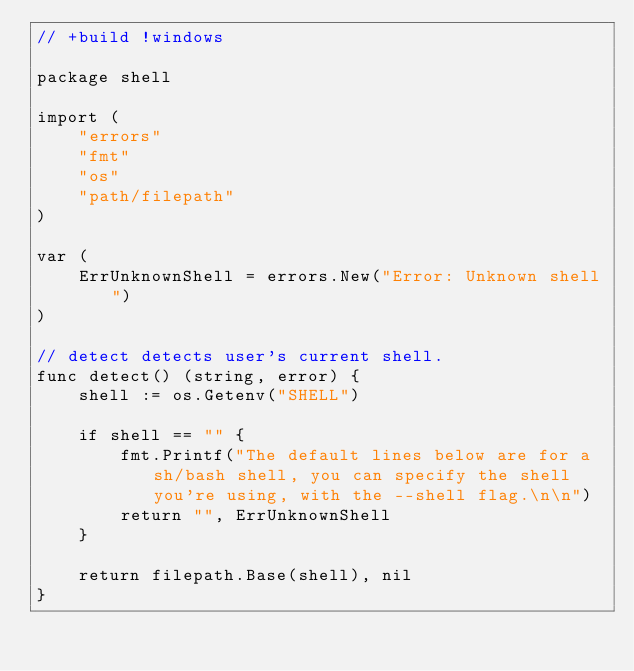<code> <loc_0><loc_0><loc_500><loc_500><_Go_>// +build !windows

package shell

import (
	"errors"
	"fmt"
	"os"
	"path/filepath"
)

var (
	ErrUnknownShell = errors.New("Error: Unknown shell")
)

// detect detects user's current shell.
func detect() (string, error) {
	shell := os.Getenv("SHELL")

	if shell == "" {
		fmt.Printf("The default lines below are for a sh/bash shell, you can specify the shell you're using, with the --shell flag.\n\n")
		return "", ErrUnknownShell
	}

	return filepath.Base(shell), nil
}
</code> 